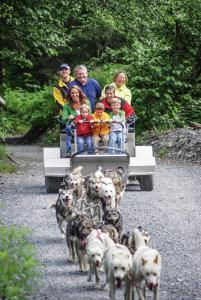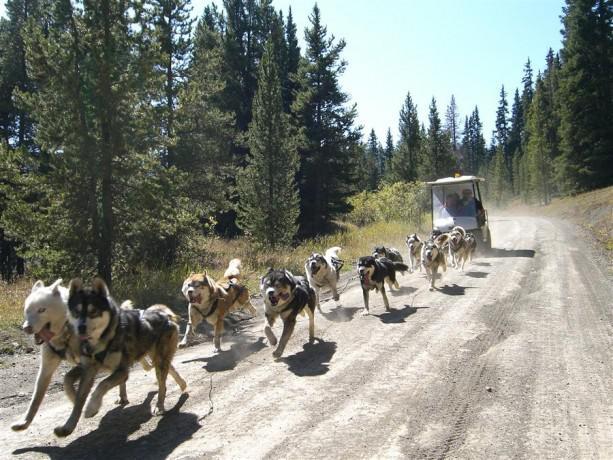The first image is the image on the left, the second image is the image on the right. Considering the images on both sides, is "One of the sleds features a single rider." valid? Answer yes or no. No. The first image is the image on the left, the second image is the image on the right. For the images shown, is this caption "One image shows a team of dogs pulling a brown sled down an unpaved path, and the other image shows a team of dogs pulling a wheeled cart with passengers along a dirt road." true? Answer yes or no. No. 